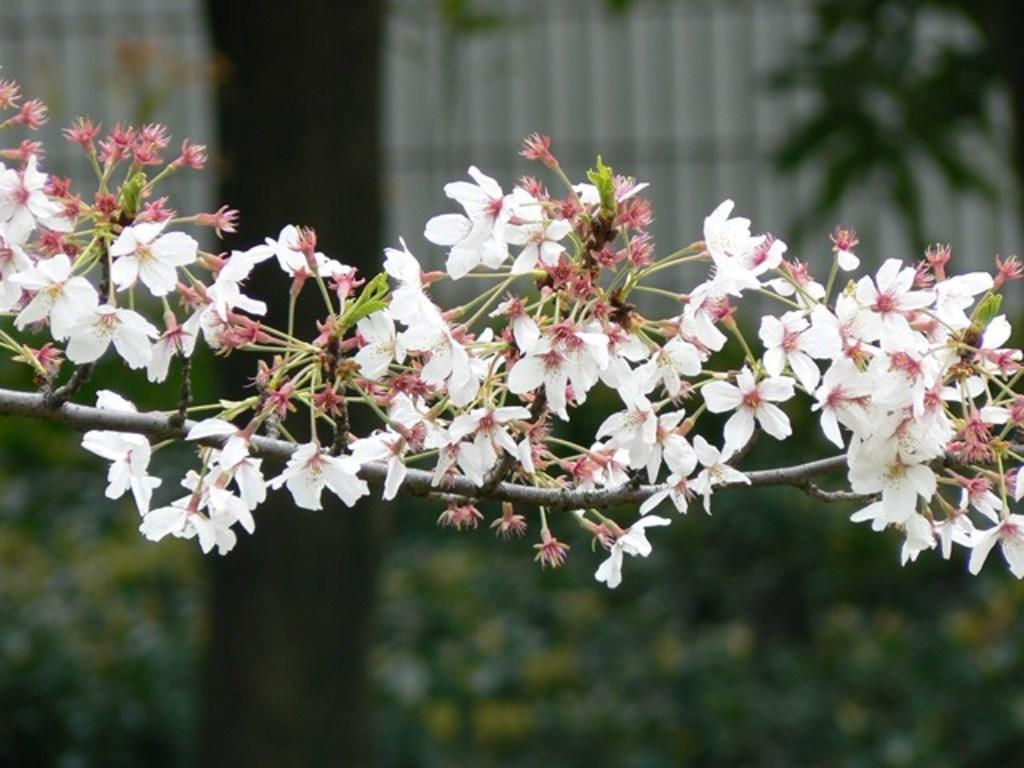What type of plants can be seen in the image? There are flowers in the image. What part of the flowers is visible in the image? There are stems in the image. How would you describe the background of the image? The background of the image is blurred. What can be seen in the background of the image? There is greenery visible in the background. What type of suit can be seen hanging on the street in the image? There is no suit or street present in the image; it features flowers and stems with a blurred background. 